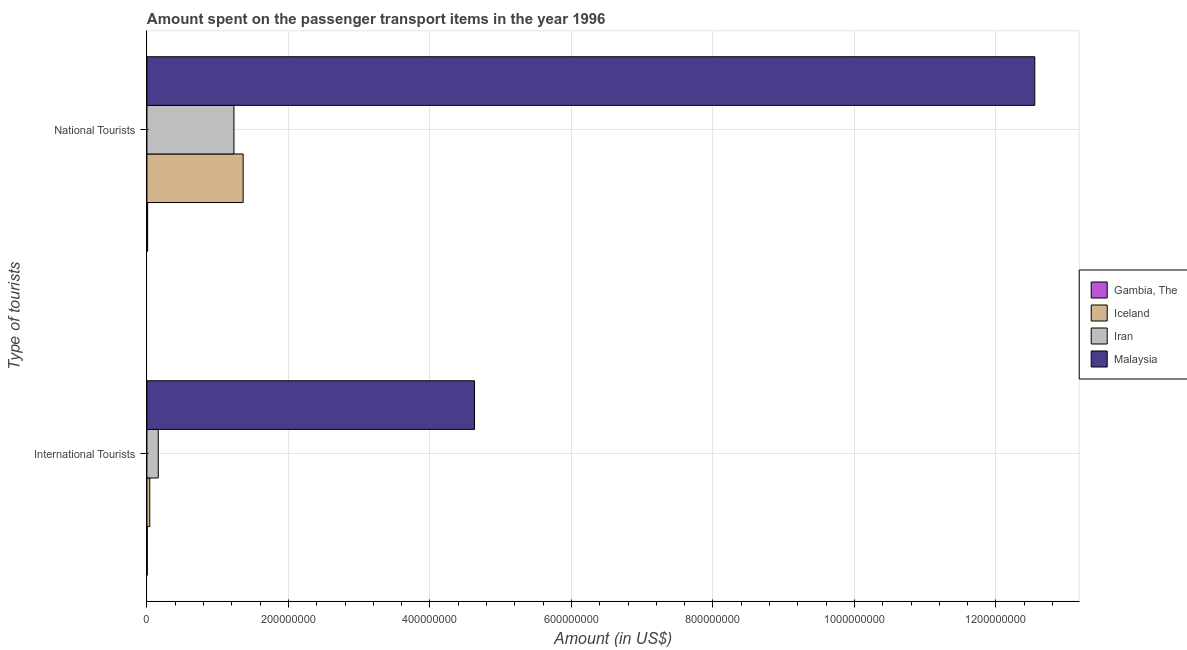How many different coloured bars are there?
Keep it short and to the point. 4. Are the number of bars per tick equal to the number of legend labels?
Your response must be concise. Yes. How many bars are there on the 1st tick from the top?
Make the answer very short. 4. What is the label of the 2nd group of bars from the top?
Keep it short and to the point. International Tourists. What is the amount spent on transport items of international tourists in Gambia, The?
Make the answer very short. 5.00e+05. Across all countries, what is the maximum amount spent on transport items of international tourists?
Ensure brevity in your answer.  4.63e+08. Across all countries, what is the minimum amount spent on transport items of national tourists?
Provide a short and direct response. 1.00e+06. In which country was the amount spent on transport items of international tourists maximum?
Ensure brevity in your answer.  Malaysia. In which country was the amount spent on transport items of international tourists minimum?
Offer a terse response. Gambia, The. What is the total amount spent on transport items of national tourists in the graph?
Give a very brief answer. 1.52e+09. What is the difference between the amount spent on transport items of national tourists in Iran and that in Malaysia?
Your answer should be very brief. -1.13e+09. What is the difference between the amount spent on transport items of national tourists in Iran and the amount spent on transport items of international tourists in Iceland?
Give a very brief answer. 1.19e+08. What is the average amount spent on transport items of national tourists per country?
Ensure brevity in your answer.  3.79e+08. What is the difference between the amount spent on transport items of international tourists and amount spent on transport items of national tourists in Gambia, The?
Ensure brevity in your answer.  -5.00e+05. What is the ratio of the amount spent on transport items of international tourists in Iran to that in Gambia, The?
Offer a very short reply. 32. Is the amount spent on transport items of international tourists in Malaysia less than that in Iran?
Provide a succinct answer. No. In how many countries, is the amount spent on transport items of international tourists greater than the average amount spent on transport items of international tourists taken over all countries?
Offer a very short reply. 1. What does the 4th bar from the top in International Tourists represents?
Your response must be concise. Gambia, The. What does the 3rd bar from the bottom in National Tourists represents?
Provide a short and direct response. Iran. Are all the bars in the graph horizontal?
Ensure brevity in your answer.  Yes. Are the values on the major ticks of X-axis written in scientific E-notation?
Offer a terse response. No. Does the graph contain any zero values?
Make the answer very short. No. Where does the legend appear in the graph?
Offer a terse response. Center right. How many legend labels are there?
Offer a very short reply. 4. How are the legend labels stacked?
Your answer should be very brief. Vertical. What is the title of the graph?
Offer a terse response. Amount spent on the passenger transport items in the year 1996. What is the label or title of the X-axis?
Your answer should be very brief. Amount (in US$). What is the label or title of the Y-axis?
Keep it short and to the point. Type of tourists. What is the Amount (in US$) in Gambia, The in International Tourists?
Make the answer very short. 5.00e+05. What is the Amount (in US$) in Iceland in International Tourists?
Keep it short and to the point. 4.00e+06. What is the Amount (in US$) of Iran in International Tourists?
Provide a succinct answer. 1.60e+07. What is the Amount (in US$) in Malaysia in International Tourists?
Your answer should be very brief. 4.63e+08. What is the Amount (in US$) in Gambia, The in National Tourists?
Your response must be concise. 1.00e+06. What is the Amount (in US$) of Iceland in National Tourists?
Your answer should be compact. 1.36e+08. What is the Amount (in US$) in Iran in National Tourists?
Keep it short and to the point. 1.23e+08. What is the Amount (in US$) of Malaysia in National Tourists?
Provide a succinct answer. 1.26e+09. Across all Type of tourists, what is the maximum Amount (in US$) in Iceland?
Provide a succinct answer. 1.36e+08. Across all Type of tourists, what is the maximum Amount (in US$) in Iran?
Make the answer very short. 1.23e+08. Across all Type of tourists, what is the maximum Amount (in US$) of Malaysia?
Keep it short and to the point. 1.26e+09. Across all Type of tourists, what is the minimum Amount (in US$) in Iceland?
Offer a very short reply. 4.00e+06. Across all Type of tourists, what is the minimum Amount (in US$) of Iran?
Provide a succinct answer. 1.60e+07. Across all Type of tourists, what is the minimum Amount (in US$) of Malaysia?
Offer a terse response. 4.63e+08. What is the total Amount (in US$) in Gambia, The in the graph?
Your answer should be compact. 1.50e+06. What is the total Amount (in US$) of Iceland in the graph?
Make the answer very short. 1.40e+08. What is the total Amount (in US$) in Iran in the graph?
Offer a very short reply. 1.39e+08. What is the total Amount (in US$) of Malaysia in the graph?
Your answer should be compact. 1.72e+09. What is the difference between the Amount (in US$) of Gambia, The in International Tourists and that in National Tourists?
Provide a short and direct response. -5.00e+05. What is the difference between the Amount (in US$) in Iceland in International Tourists and that in National Tourists?
Give a very brief answer. -1.32e+08. What is the difference between the Amount (in US$) in Iran in International Tourists and that in National Tourists?
Provide a succinct answer. -1.07e+08. What is the difference between the Amount (in US$) of Malaysia in International Tourists and that in National Tourists?
Keep it short and to the point. -7.92e+08. What is the difference between the Amount (in US$) of Gambia, The in International Tourists and the Amount (in US$) of Iceland in National Tourists?
Keep it short and to the point. -1.36e+08. What is the difference between the Amount (in US$) of Gambia, The in International Tourists and the Amount (in US$) of Iran in National Tourists?
Provide a short and direct response. -1.22e+08. What is the difference between the Amount (in US$) in Gambia, The in International Tourists and the Amount (in US$) in Malaysia in National Tourists?
Give a very brief answer. -1.25e+09. What is the difference between the Amount (in US$) of Iceland in International Tourists and the Amount (in US$) of Iran in National Tourists?
Your answer should be very brief. -1.19e+08. What is the difference between the Amount (in US$) of Iceland in International Tourists and the Amount (in US$) of Malaysia in National Tourists?
Keep it short and to the point. -1.25e+09. What is the difference between the Amount (in US$) of Iran in International Tourists and the Amount (in US$) of Malaysia in National Tourists?
Provide a short and direct response. -1.24e+09. What is the average Amount (in US$) in Gambia, The per Type of tourists?
Your answer should be very brief. 7.50e+05. What is the average Amount (in US$) in Iceland per Type of tourists?
Make the answer very short. 7.00e+07. What is the average Amount (in US$) of Iran per Type of tourists?
Your response must be concise. 6.95e+07. What is the average Amount (in US$) of Malaysia per Type of tourists?
Provide a short and direct response. 8.59e+08. What is the difference between the Amount (in US$) of Gambia, The and Amount (in US$) of Iceland in International Tourists?
Give a very brief answer. -3.50e+06. What is the difference between the Amount (in US$) in Gambia, The and Amount (in US$) in Iran in International Tourists?
Give a very brief answer. -1.55e+07. What is the difference between the Amount (in US$) of Gambia, The and Amount (in US$) of Malaysia in International Tourists?
Your response must be concise. -4.62e+08. What is the difference between the Amount (in US$) in Iceland and Amount (in US$) in Iran in International Tourists?
Offer a very short reply. -1.20e+07. What is the difference between the Amount (in US$) of Iceland and Amount (in US$) of Malaysia in International Tourists?
Give a very brief answer. -4.59e+08. What is the difference between the Amount (in US$) in Iran and Amount (in US$) in Malaysia in International Tourists?
Offer a terse response. -4.47e+08. What is the difference between the Amount (in US$) in Gambia, The and Amount (in US$) in Iceland in National Tourists?
Ensure brevity in your answer.  -1.35e+08. What is the difference between the Amount (in US$) of Gambia, The and Amount (in US$) of Iran in National Tourists?
Your response must be concise. -1.22e+08. What is the difference between the Amount (in US$) of Gambia, The and Amount (in US$) of Malaysia in National Tourists?
Your answer should be compact. -1.25e+09. What is the difference between the Amount (in US$) in Iceland and Amount (in US$) in Iran in National Tourists?
Ensure brevity in your answer.  1.30e+07. What is the difference between the Amount (in US$) of Iceland and Amount (in US$) of Malaysia in National Tourists?
Your answer should be very brief. -1.12e+09. What is the difference between the Amount (in US$) of Iran and Amount (in US$) of Malaysia in National Tourists?
Ensure brevity in your answer.  -1.13e+09. What is the ratio of the Amount (in US$) of Gambia, The in International Tourists to that in National Tourists?
Make the answer very short. 0.5. What is the ratio of the Amount (in US$) of Iceland in International Tourists to that in National Tourists?
Give a very brief answer. 0.03. What is the ratio of the Amount (in US$) in Iran in International Tourists to that in National Tourists?
Ensure brevity in your answer.  0.13. What is the ratio of the Amount (in US$) of Malaysia in International Tourists to that in National Tourists?
Your answer should be very brief. 0.37. What is the difference between the highest and the second highest Amount (in US$) of Iceland?
Provide a succinct answer. 1.32e+08. What is the difference between the highest and the second highest Amount (in US$) in Iran?
Ensure brevity in your answer.  1.07e+08. What is the difference between the highest and the second highest Amount (in US$) in Malaysia?
Keep it short and to the point. 7.92e+08. What is the difference between the highest and the lowest Amount (in US$) in Iceland?
Provide a succinct answer. 1.32e+08. What is the difference between the highest and the lowest Amount (in US$) of Iran?
Ensure brevity in your answer.  1.07e+08. What is the difference between the highest and the lowest Amount (in US$) in Malaysia?
Offer a very short reply. 7.92e+08. 